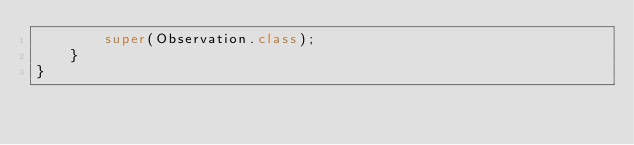<code> <loc_0><loc_0><loc_500><loc_500><_Java_>        super(Observation.class);
    }
}
</code> 